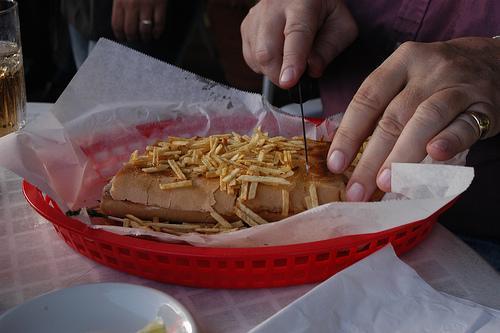How many sandwiches are there?
Give a very brief answer. 1. 